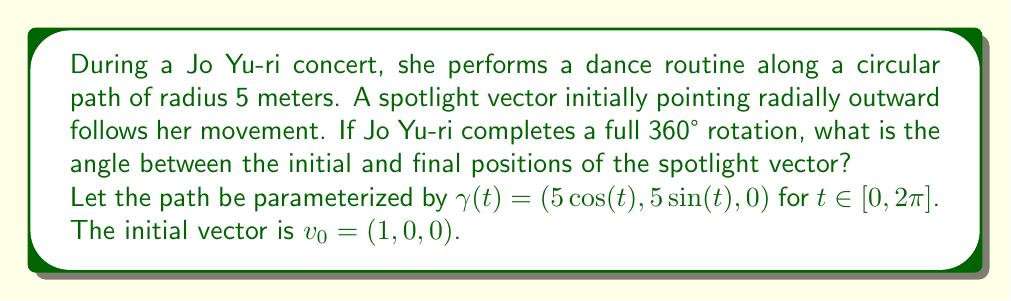Show me your answer to this math problem. To solve this problem, we'll use the concept of parallel transport along a curve:

1) The Christoffel symbols for a circular path in polar coordinates are:
   $\Gamma^r_{\theta\theta} = -r$ and $\Gamma^\theta_{r\theta} = \Gamma^\theta_{\theta r} = \frac{1}{r}$

2) The parallel transport equation in this case is:
   $$\frac{dv^r}{dt} - rv^\theta\frac{d\theta}{dt} = 0$$
   $$\frac{dv^\theta}{dt} + \frac{1}{r}v^r\frac{d\theta}{dt} = 0$$

3) For a circular path, $r$ is constant and $\frac{d\theta}{dt} = 1$. The equations become:
   $$\frac{dv^r}{dt} - 5v^\theta = 0$$
   $$\frac{dv^\theta}{dt} + \frac{1}{5}v^r = 0$$

4) This system has the general solution:
   $$v^r = A\cos(\frac{t}{5}) + B\sin(\frac{t}{5})$$
   $$v^\theta = -A\sin(\frac{t}{5}) + B\cos(\frac{t}{5})$$

5) With initial conditions $v^r(0) = 1$ and $v^\theta(0) = 0$, we get $A = 1$ and $B = 0$:
   $$v^r = \cos(\frac{t}{5})$$
   $$v^\theta = -\sin(\frac{t}{5})$$

6) After a full rotation, $t = 2\pi$, so:
   $$v^r(2\pi) = \cos(\frac{2\pi}{5}) \approx 0.3090$$
   $$v^\theta(2\pi) = -\sin(\frac{2\pi}{5}) \approx -0.9511$$

7) The angle between the initial and final vectors is:
   $$\theta = \arccos(\frac{v_0 \cdot v(2\pi)}{|v_0||v(2\pi)|}) = \arccos(\cos(\frac{2\pi}{5})) = \frac{2\pi}{5}$$
Answer: $\frac{2\pi}{5}$ radians or 72° 